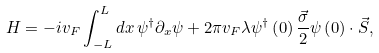Convert formula to latex. <formula><loc_0><loc_0><loc_500><loc_500>H = - i v _ { F } \int _ { - L } ^ { L } d x \, \psi ^ { \dagger } \partial _ { x } \psi + 2 \pi v _ { F } \lambda \psi ^ { \dagger } \left ( 0 \right ) \frac { \vec { \sigma } } { 2 } \psi \left ( 0 \right ) \cdot \vec { S } ,</formula> 